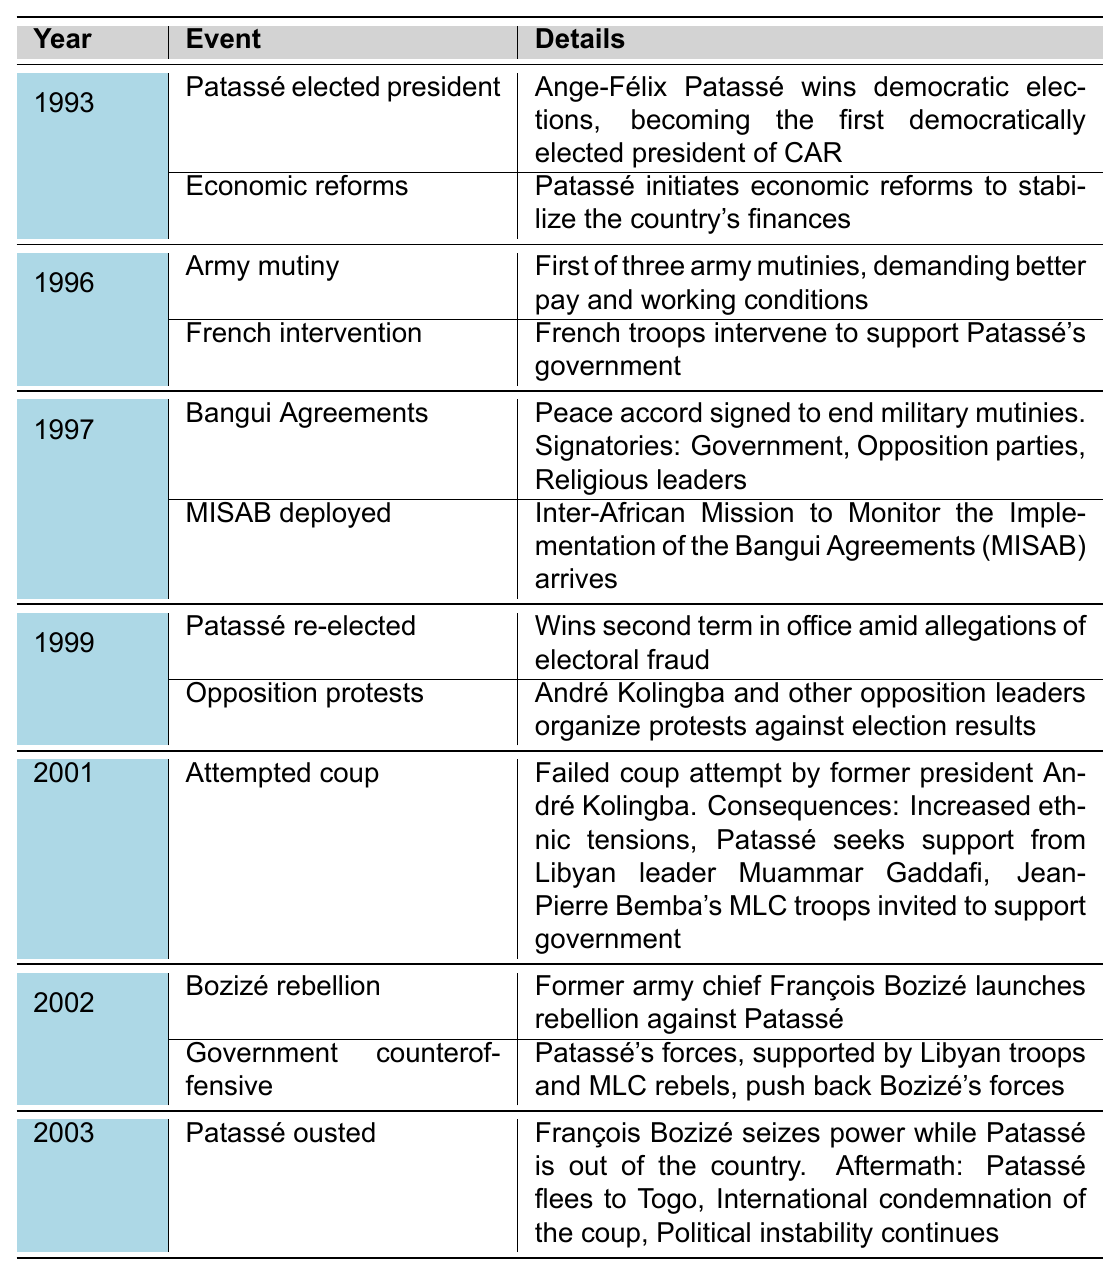What significant event occurred in 1993? The table lists two events for 1993: Patassé's election as president and the initiation of economic reforms. These events are notable because they mark the beginning of Patassé's presidency.
Answer: Patassé elected president Which countries intervened to support Patassé's government in 1996? The table indicates that in 1996, French troops intervened to support Patassé's government amid the army mutiny. There are no other countries mentioned in this event.
Answer: France How many army mutinies occurred during Patassé's presidency? The table specifies that there were three army mutinies, with the first one occurring in 1996. It does not count additional mutinies but notes that the first was significant.
Answer: Three army mutinies What were the consequences of the attempted coup in 2001? The table outlines several consequences stemming from the 2001 attempted coup: increased ethnic tensions, Patassé seeking support from Muammar Gaddafi, and the invitation of Jean-Pierre Bemba's MLC troops.
Answer: Increased ethnic tensions, support from Gaddafi, MLC troops invitation Did Patassé face protests after the 1999 elections? The table indicates that after the 1999 elections, there were indeed organized protests against the election results led by André Kolingba and other opposition leaders.
Answer: Yes In which year did Patassé sign the Bangui Agreements? According to the table, the Bangui Agreements were signed in 1997 as a peace accord intended to end military mutinies.
Answer: 1997 What can we infer about Patassé's leadership style based on the timeline? Analyzing the timeline, it can be inferred that Patassé's leadership was marked by attempts at democratic reforms, significant internal conflicts, and reliance on foreign support during crises, showcasing a complex and tumultuous governance.
Answer: Complex governance under pressure Which event directly followed the signing of the Bangui Agreements? The deployment of the Inter-African Mission to Monitor the Implementation of the Bangui Agreements (MISAB) occurred directly after the signing of the Bangui Agreements in 1997, indicating international involvement in ensuring the peace accord was upheld.
Answer: MISAB deployed What was the main reason for Patassé's ousting in 2003? The table reveals that Patassé was ousted by François Bozizé, who seized power while Patassé was out of the country, which indicates a significant loss of control and influence at that moment.
Answer: François Bozizé seized power Based on the events listed, which year saw the most significant upheaval for Patassé's presidency? By analyzing the events, the year 2001 stands out as particularly significant due to the attempted coup, which led to increased ethnic tensions, involvement of foreign leaders, and troop support, indicating a peak in political instability.
Answer: 2001 